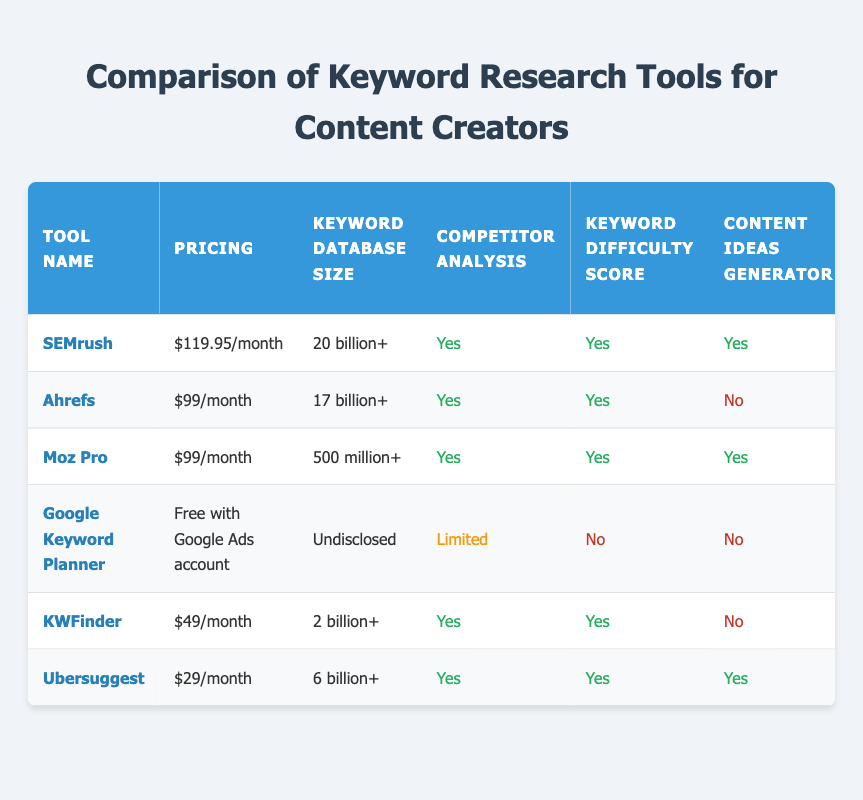What is the pricing for KWFinder? The table lists the pricing for KWFinder in the "Pricing" column, which states it is $49/month.
Answer: $49/month Which tool has the largest keyword database size? By comparing the "Keyword Database Size" entries in the table, SEMrush has the largest database at "20 billion+".
Answer: SEMrush Does Ubersuggest provide a Content Ideas Generator? Looking under the "Content Ideas Generator" column, Ubersuggest is marked with a "Yes", indicating it provides this feature.
Answer: Yes What is the keyword difficulty score availability for Google Keyword Planner? Under the "Keyword Difficulty Score" column for Google Keyword Planner, it is marked "No", meaning it does not offer a score for keyword difficulty.
Answer: No Which tools have limited integration with writing tools? By reviewing the "Integration with Writing Tools" column, SEMrush and Moz Pro are marked as "Limited" in integration. Therefore, both tools have this characteristic.
Answer: SEMrush and Moz Pro What is the average monthly pricing of the tools listed? The monthly prices for the tools are $119.95, $99, $99, $0 (free with Google Ads), $49, and $29. Calculating the total ($119.95 + $99 + $99 + $0 + $49 + $29 = $395.95), dividing that by the 6 tools gives an average of $65.99.
Answer: $65.99 Which tools allow competitor analysis? Looking at the "Competitor Analysis" column, all tools except Google Keyword Planner offer "Yes" for competitor analysis. These tools are SEMrush, Ahrefs, Moz Pro, KWFinder, and Ubersuggest.
Answer: SEMrush, Ahrefs, Moz Pro, KWFinder, and Ubersuggest Is there any tool that offers both a Content Ideas Generator and keyword difficulty score? By checking the "Content Ideas Generator" and "Keyword Difficulty Score" columns, tools like SEMrush, Moz Pro, and Ubersuggest offer "Yes" for both features.
Answer: SEMrush, Moz Pro, and Ubersuggest How many tools offer Search Volume Trends? By checking the "Search Volume Trends" column, it appears that all tools except Google Keyword Planner offer "Yes". Thus, five tools provide this feature.
Answer: Five tools 